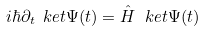<formula> <loc_0><loc_0><loc_500><loc_500>i \hbar { \partial } _ { t } \ k e t { \Psi ( t ) } = \hat { H } \, \ k e t { \Psi ( t ) }</formula> 